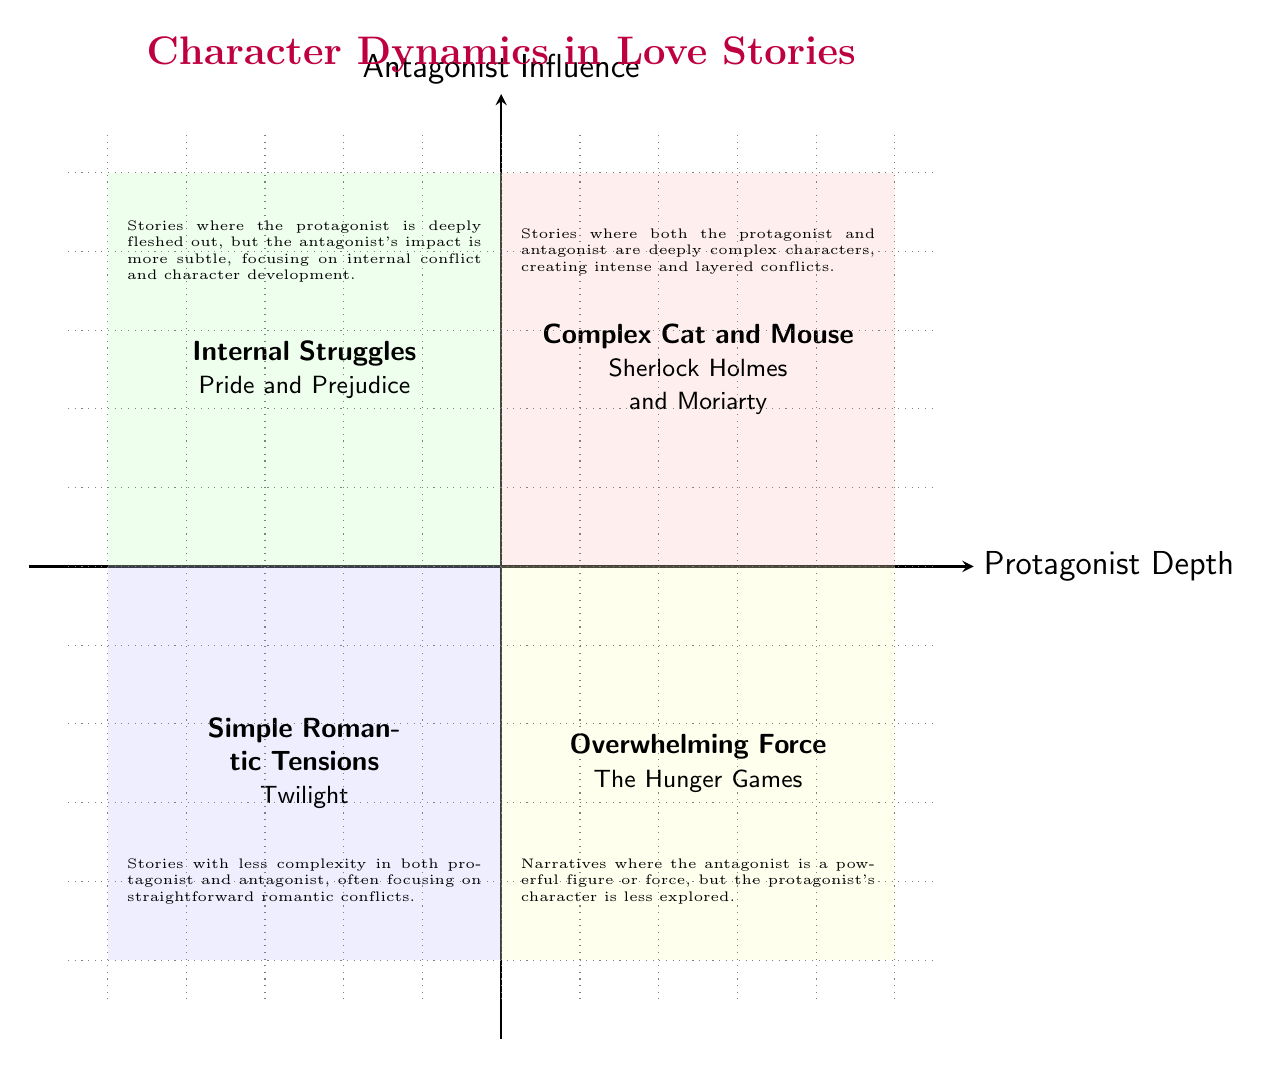What is the title of the quadrant located in the high protagonist depth and high antagonist influence area? The quadrant in the high protagonist depth and high antagonist influence area is titled "Complex Cat and Mouse." This is directly indicated in the quadrant chart.
Answer: Complex Cat and Mouse Which example character pair is used to illustrate the "Overwhelming Force" quadrant? The "Overwhelming Force" quadrant provides the example of Katniss Everdeen and President Snow, which is explicitly stated in the chart.
Answer: Katniss Everdeen and President Snow How many quadrants are shown in the diagram? The diagram displays four distinct quadrants, each corresponding to different dynamics of character depth and influence. This is a count of the sections formed by the axes.
Answer: Four What type of conflicts are described in the "Simple Romantic Tensions" quadrant? The "Simple Romantic Tensions" quadrant focuses on straightforward romantic conflicts, as described in the quadrant's text. This involves less complexity in character dynamics.
Answer: Straightforward romantic conflicts In which quadrant is the protagonist deeply fleshed out while the antagonist's impact is subtle? This characteristic is found in the "Internal Struggles" quadrant, where the protagonist is complex, but the antagonist's role is more understated. This is detailed in the quadrant description.
Answer: Internal Struggles Which quadrant features less complex characters in both the protagonist and antagonist? The quadrant featuring less complexity in both the protagonist and antagonist is "Simple Romantic Tensions," as indicated by its description.
Answer: Simple Romantic Tensions How would you categorize the overall character dynamics in "Pride and Prejudice"? "Pride and Prejudice" is categorized in the "Internal Struggles" quadrant, where the protagonist's depth is emphasized alongside the subtler influence of the antagonist. This is derived from the example given for that quadrant.
Answer: Internal Struggles Which quadrant's description mentions intense and layered conflicts? The description mentioning intense and layered conflicts pertains to the "Complex Cat and Mouse" quadrant, which directly points out the depth of interactions between the characters.
Answer: Complex Cat and Mouse 